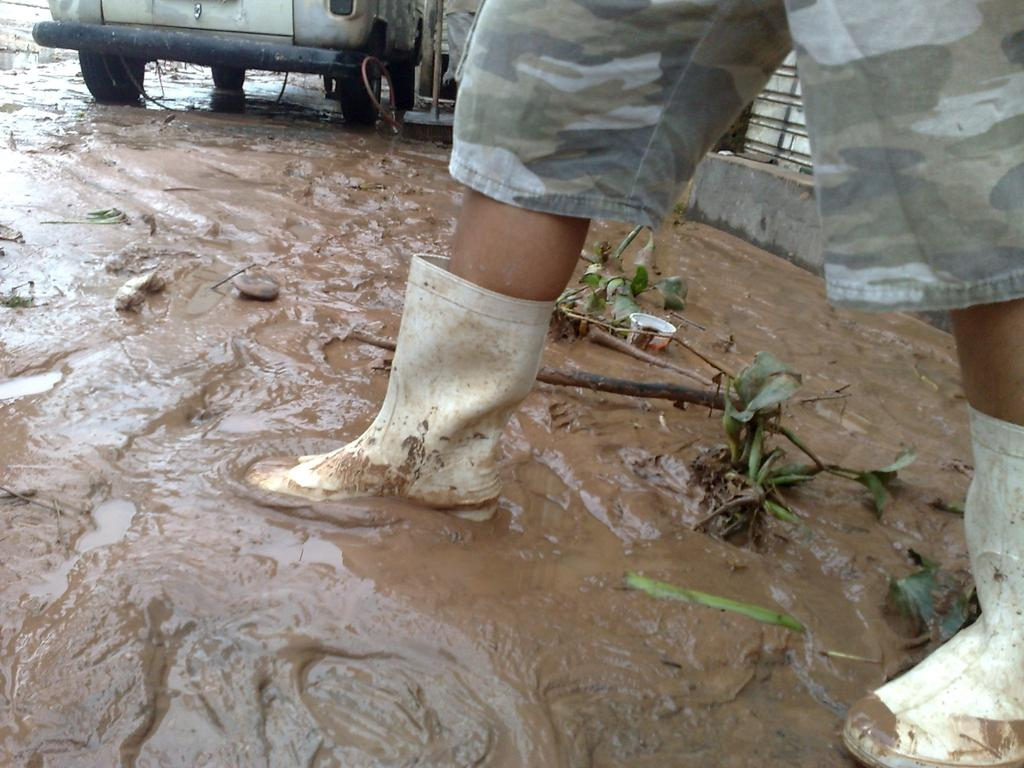What part of a person can be seen in the image? There are legs of a person visible in the image. What is located behind the person in the image? There are plants and a wall behind the person in the image. What type of terrain is visible in the image? There is mud visible in the image. Where is the vehicle located in the image? The vehicle is in the top left corner of the image. What type of pie is being served on a plate in the image? There is no pie present in the image; it features a person's legs, plants, a wall, mud, and a vehicle. Can you tell me how many guitars are visible in the image? There are no guitars present in the image. 